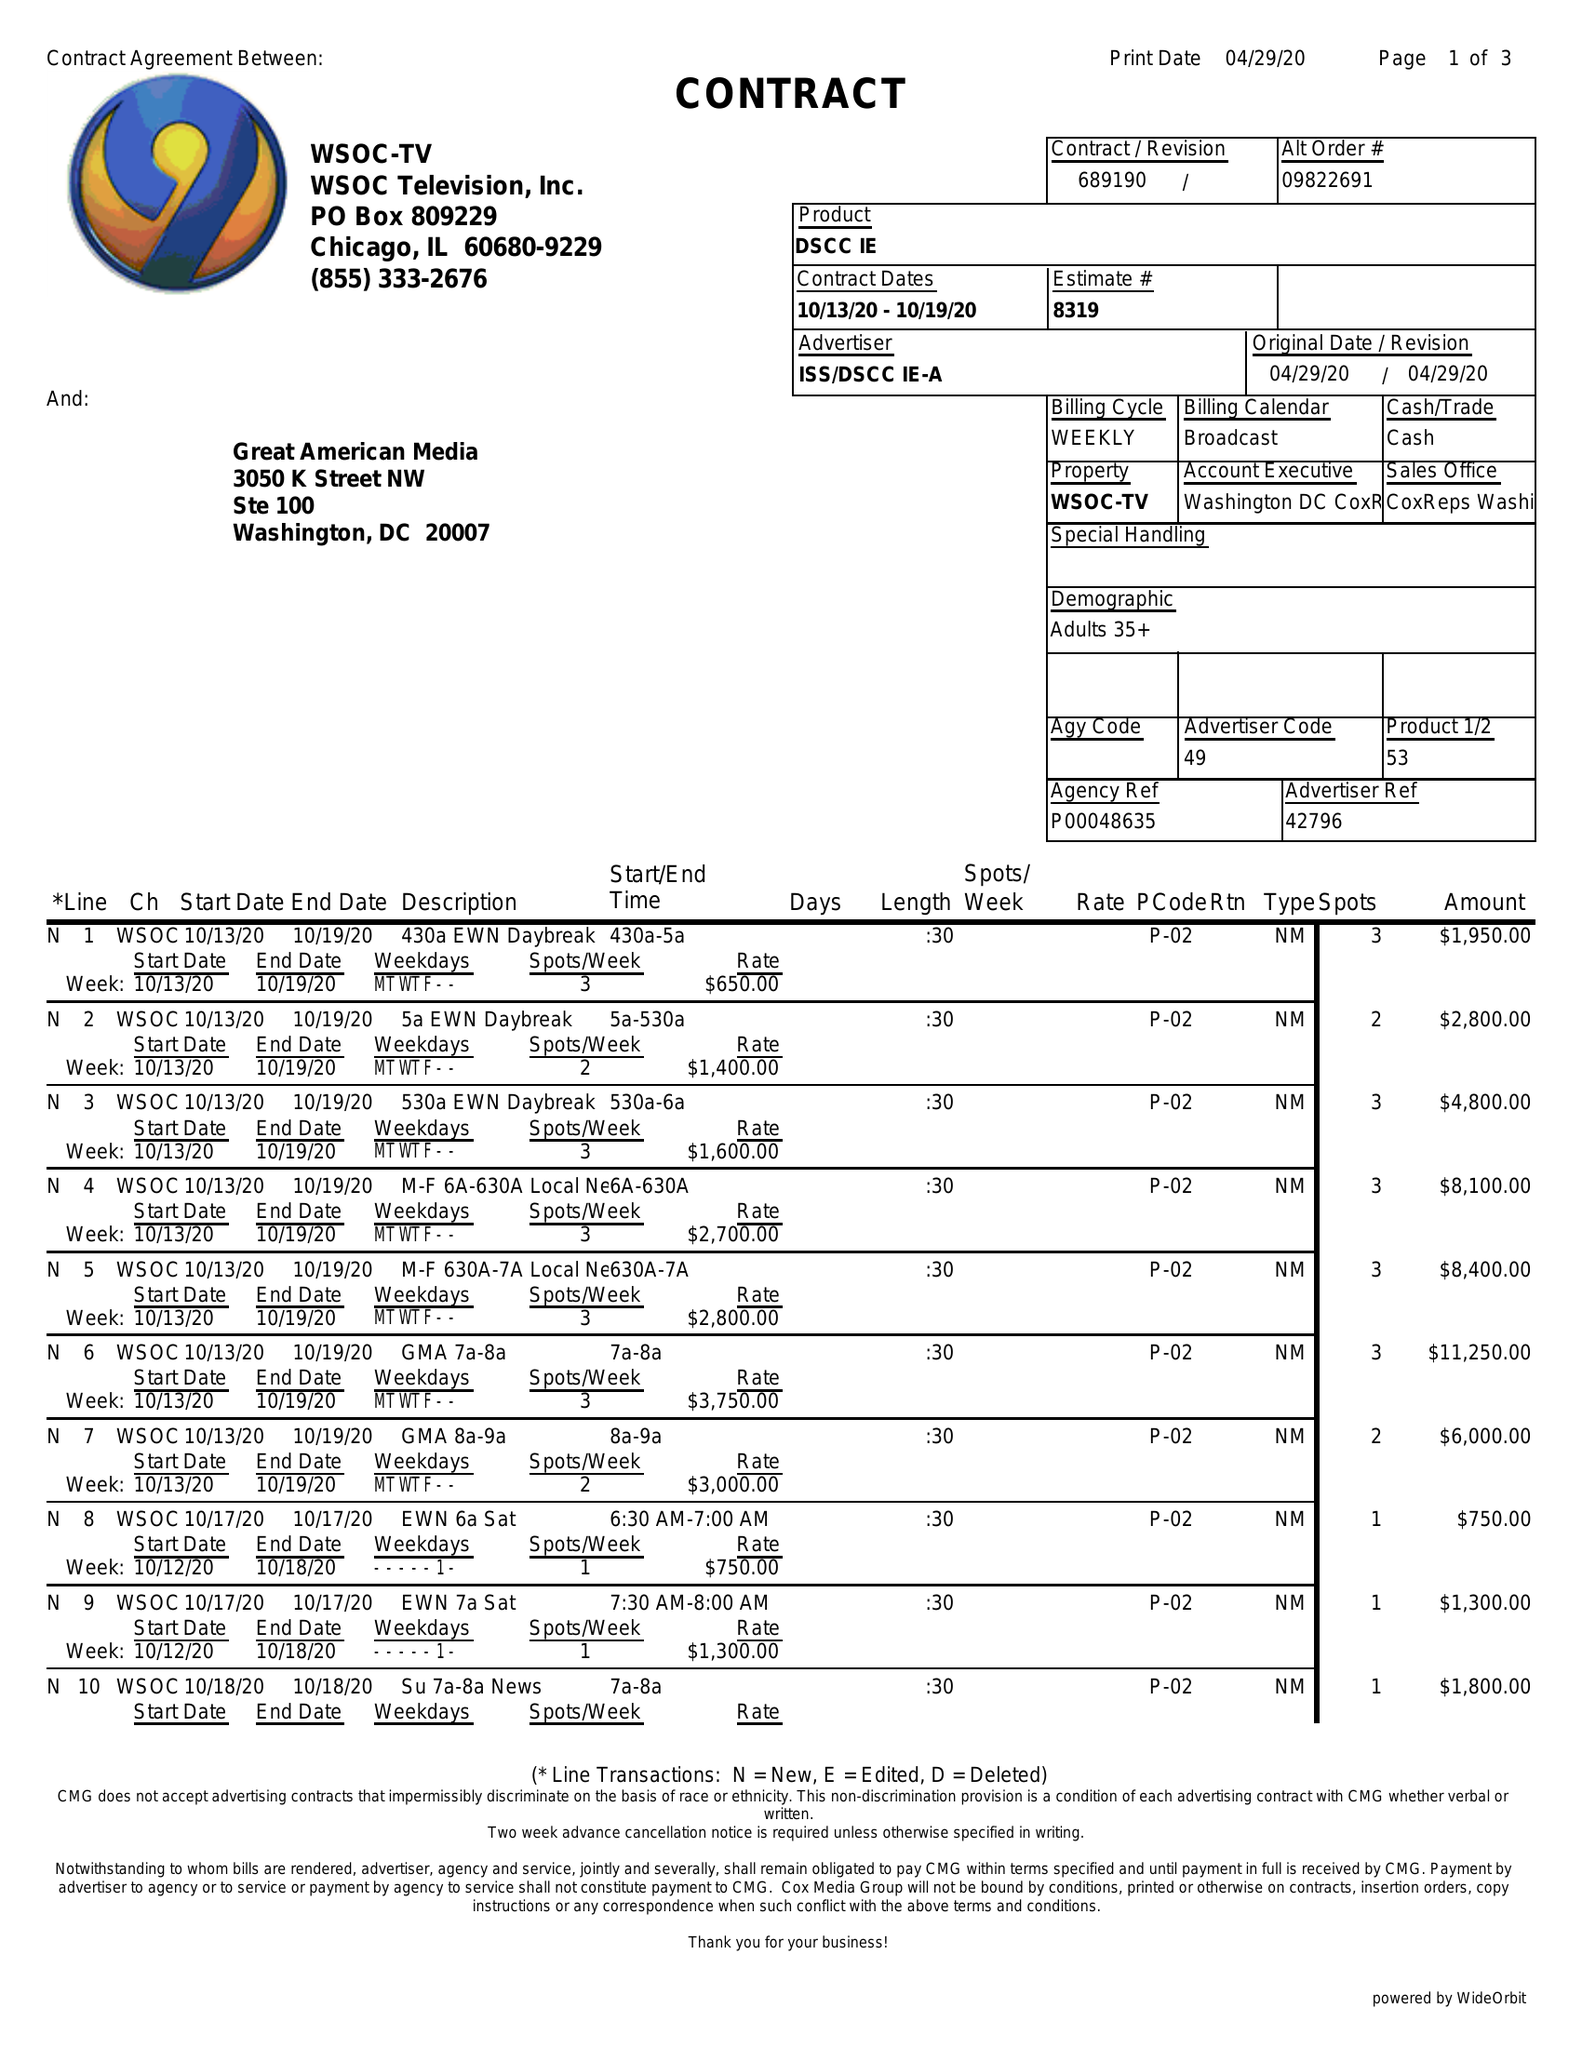What is the value for the flight_from?
Answer the question using a single word or phrase. 10/13/20 